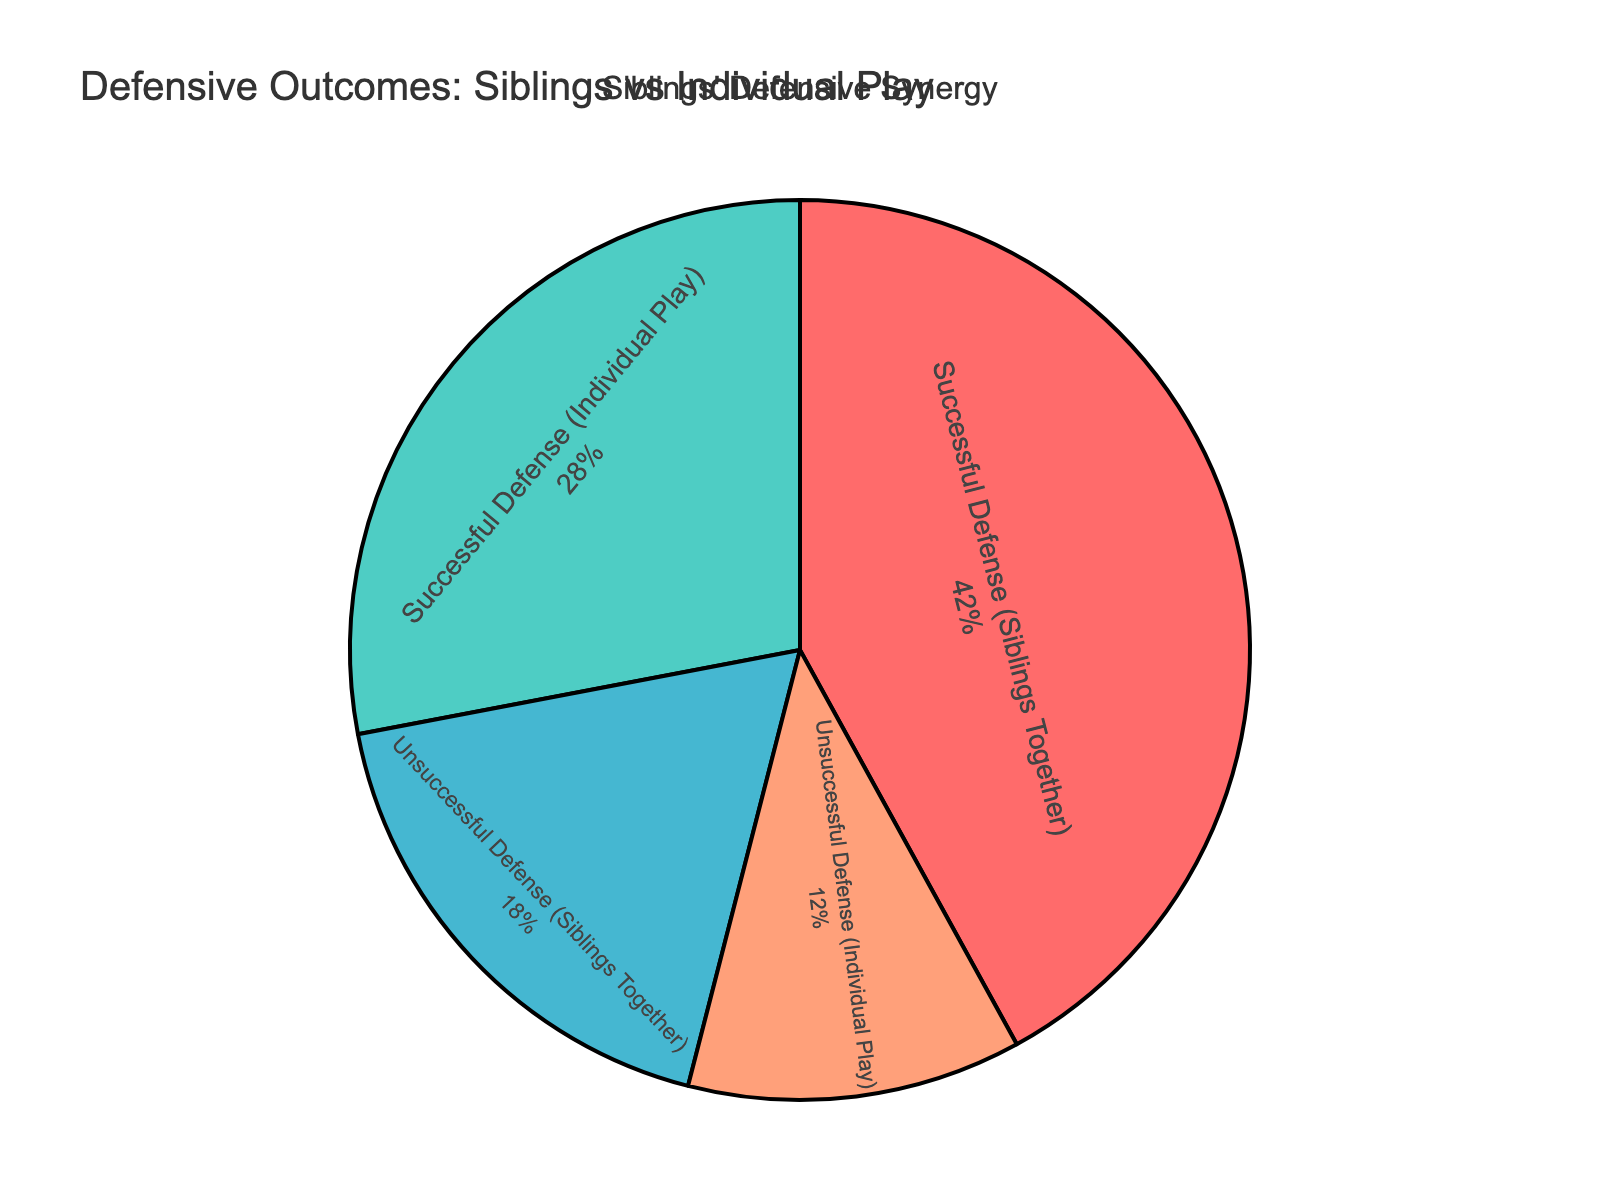What percentage of successful defenses were achieved by siblings working together? In the pie chart, the slice labeled "Successful Defense (Siblings Together)" has a percentage value of 42%.
Answer: 42% What is the combined percentage of unsuccessful defenses regardless of whether siblings are working together or individually? To find the combined percentage of unsuccessful defenses, add the percentages of "Unsuccessful Defense (Siblings Together)" and "Unsuccessful Defense (Individual Play)". That is 18% + 12% = 30%.
Answer: 30% Which category has the lowest percentage and what is that percentage? The pie chart shows the lowest percentage for "Unsuccessful Defense (Individual Play)" which is 12%.
Answer: Unsuccessful Defense (Individual Play), 12% How much higher is the percentage of successful defenses when siblings work together compared to when they play individually? Subtract the percentage of "Successful Defense (Individual Play)" from "Successful Defense (Siblings Together)". That is 42% - 28% = 14%.
Answer: 14% What is the total percentage of defenses (both successful and unsuccessful) achieved when siblings play together? Add the percentages of "Successful Defense (Siblings Together)" and "Unsuccessful Defense (Siblings Together)": 42% + 18% = 60%.
Answer: 60% Which category shows a better performance in terms of successful defenses: siblings working together or individual play? The pie chart indicates that "Successful Defense (Siblings Together)" is 42%, which is higher than "Successful Defense (Individual Play)" at 28%. Therefore, siblings working together show better performance.
Answer: Siblings working together How does the percentage of unsuccessful defenses when siblings play together compare to when they play individually? Compare the percentages of "Unsuccessful Defense (Siblings Together)" and "Unsuccessful Defense (Individual Play)". The former is 18% and the latter is 12%. So, the unsuccessful defenses when siblings play together are higher by 6%.
Answer: 6% What is the percentage difference between successful and unsuccessful defenses when siblings play together? Subtract the percentage of "Unsuccessful Defense (Siblings Together)" from "Successful Defense (Siblings Together)". That is 42% - 18% = 24%.
Answer: 24% How much greater is the percentage of successful defenses compared to unsuccessful defenses overall? Add the percentages of successful defenses (42% + 28% = 70%) and unsuccessful defenses (18% + 12% = 30%). Subtract the total percentage of unsuccessful from successful: 70% - 30% = 40%.
Answer: 40% Which categories are represented by the red and blue segments, respectively, in the pie chart? Visually identify the colors shown in the pie chart: the red segment represents "Successful Defense (Siblings Together)" and the blue segment represents "Unsuccessful Defense (Siblings Together)" as per the color scheme.
Answer: Red: Successful Defense (Siblings Together), Blue: Unsuccessful Defense (Siblings Together) 